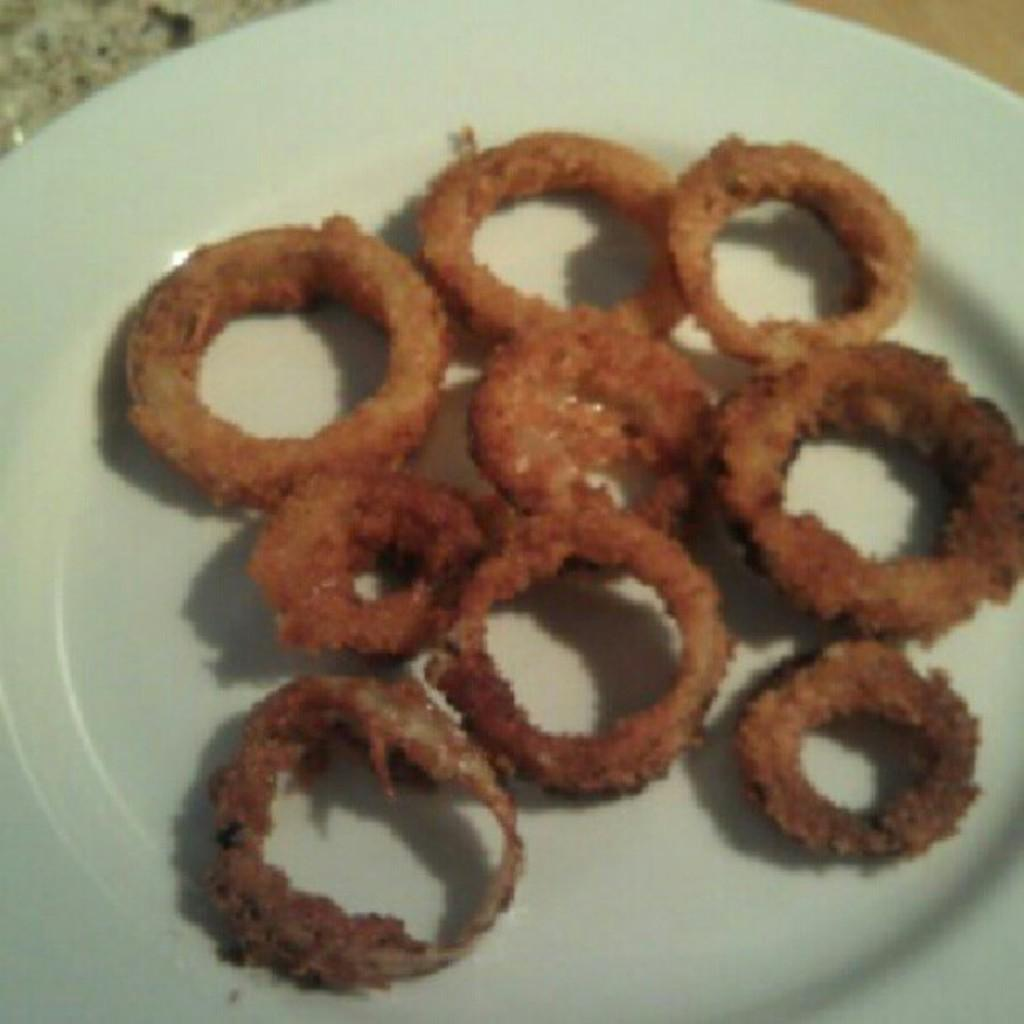What color is the plate in the image? The plate in the image is white. What type of food is on the plate? There is brown color food on the plate. What type of brass instrument is being played in the image? There is no brass instrument or any indication of music being played in the image; it only features a white color plate with brown food on it. 